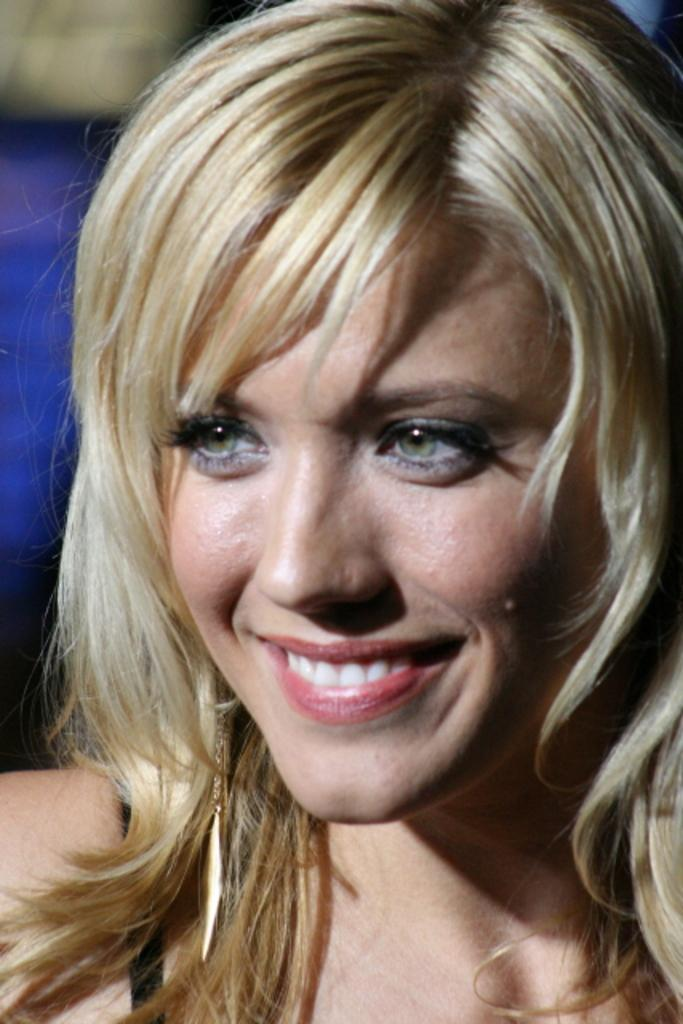What can be observed about the background of the image? The background of the image is blurred. What is the main subject in the image? There is a woman in the middle of the image. How does the woman appear to be feeling in the image? The woman has a smiling face, which suggests she is happy or content. What type of book is the woman holding in the image? There is no book present in the image; the woman is not holding any object. 